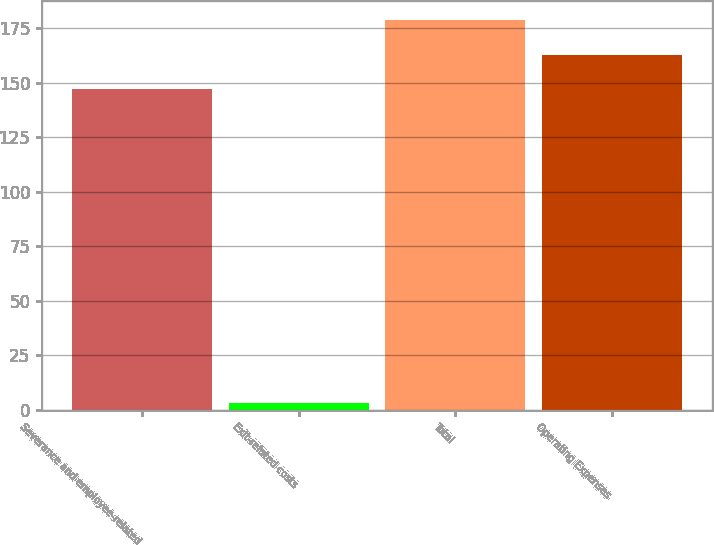<chart> <loc_0><loc_0><loc_500><loc_500><bar_chart><fcel>Severance and employee-related<fcel>Exit-related costs<fcel>Total<fcel>Operating Expenses<nl><fcel>147<fcel>3<fcel>178.6<fcel>162.8<nl></chart> 